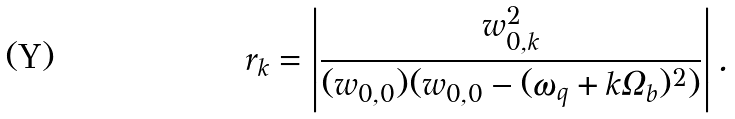Convert formula to latex. <formula><loc_0><loc_0><loc_500><loc_500>r _ { k } = \left | \frac { w _ { 0 , k } ^ { 2 } } { ( w _ { 0 , 0 } ) ( w _ { 0 , 0 } - ( \omega _ { q } + k \Omega _ { b } ) ^ { 2 } ) } \right | .</formula> 